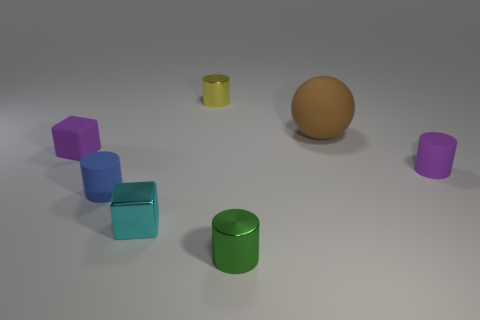How many objects are there, and can you describe their arrangement? There are seven objects in total. Starting from the bottom-left, there are three blue matte cubes, each aligned and increasing in size towards the middle of the scene, followed by a green matte cylinder. On the right, there's a larger orange sphere, flanked by a purple matte cylinder and a smaller yellow matte cylinder. They are all set against a neutral grey background.  What could be the possible purpose of this arrangement? The arrangement of the objects may serve several purposes. It could be a simple aesthetic composition designed to showcase colors and shapes, or a setup for a study of lighting and shadow in a 3D rendering software. Alternatively, it might be a part of a cognitive test for pattern recognition and spatial intelligence. 